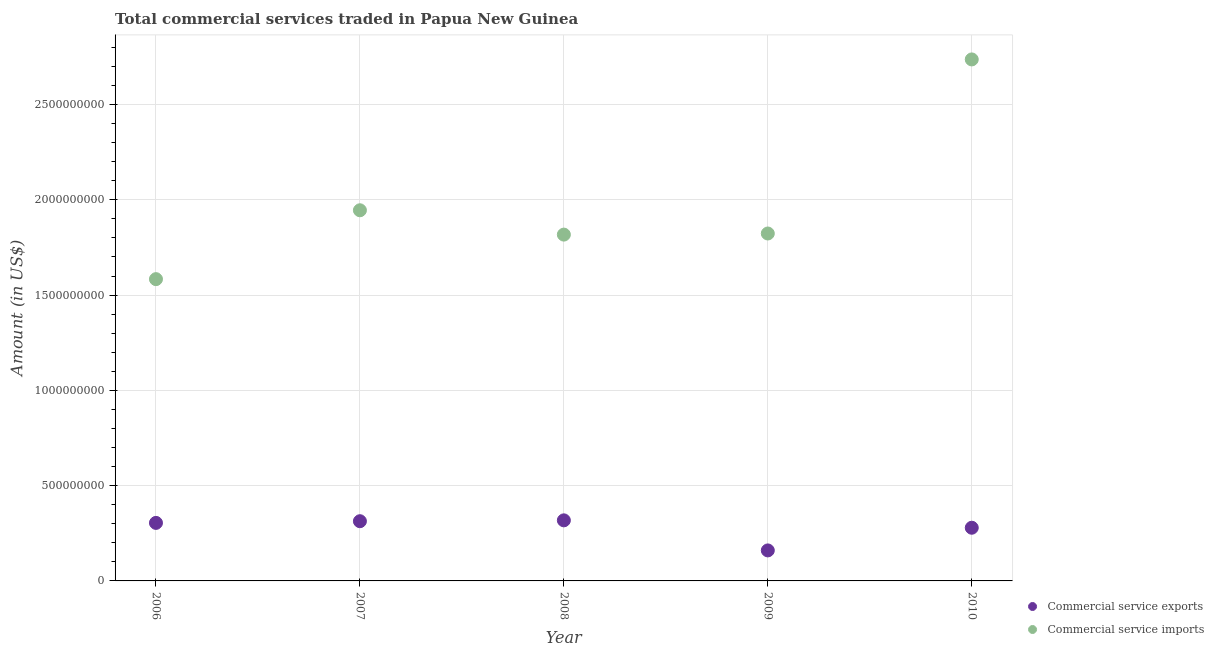How many different coloured dotlines are there?
Your response must be concise. 2. What is the amount of commercial service exports in 2009?
Offer a terse response. 1.60e+08. Across all years, what is the maximum amount of commercial service imports?
Provide a short and direct response. 2.74e+09. Across all years, what is the minimum amount of commercial service imports?
Your answer should be compact. 1.58e+09. In which year was the amount of commercial service exports minimum?
Give a very brief answer. 2009. What is the total amount of commercial service exports in the graph?
Make the answer very short. 1.38e+09. What is the difference between the amount of commercial service imports in 2007 and that in 2009?
Provide a succinct answer. 1.22e+08. What is the difference between the amount of commercial service imports in 2010 and the amount of commercial service exports in 2006?
Keep it short and to the point. 2.43e+09. What is the average amount of commercial service exports per year?
Your answer should be compact. 2.75e+08. In the year 2010, what is the difference between the amount of commercial service imports and amount of commercial service exports?
Give a very brief answer. 2.46e+09. In how many years, is the amount of commercial service imports greater than 100000000 US$?
Your answer should be compact. 5. What is the ratio of the amount of commercial service exports in 2006 to that in 2009?
Offer a very short reply. 1.9. What is the difference between the highest and the second highest amount of commercial service exports?
Offer a terse response. 4.53e+06. What is the difference between the highest and the lowest amount of commercial service imports?
Provide a succinct answer. 1.15e+09. Is the sum of the amount of commercial service exports in 2006 and 2008 greater than the maximum amount of commercial service imports across all years?
Offer a terse response. No. Is the amount of commercial service exports strictly greater than the amount of commercial service imports over the years?
Give a very brief answer. No. Is the amount of commercial service imports strictly less than the amount of commercial service exports over the years?
Ensure brevity in your answer.  No. How many years are there in the graph?
Your answer should be compact. 5. How are the legend labels stacked?
Offer a very short reply. Vertical. What is the title of the graph?
Provide a short and direct response. Total commercial services traded in Papua New Guinea. Does "Investment" appear as one of the legend labels in the graph?
Offer a very short reply. No. What is the Amount (in US$) of Commercial service exports in 2006?
Make the answer very short. 3.05e+08. What is the Amount (in US$) of Commercial service imports in 2006?
Offer a terse response. 1.58e+09. What is the Amount (in US$) of Commercial service exports in 2007?
Offer a terse response. 3.13e+08. What is the Amount (in US$) in Commercial service imports in 2007?
Offer a terse response. 1.95e+09. What is the Amount (in US$) of Commercial service exports in 2008?
Provide a succinct answer. 3.18e+08. What is the Amount (in US$) in Commercial service imports in 2008?
Provide a succinct answer. 1.82e+09. What is the Amount (in US$) in Commercial service exports in 2009?
Provide a succinct answer. 1.60e+08. What is the Amount (in US$) of Commercial service imports in 2009?
Keep it short and to the point. 1.82e+09. What is the Amount (in US$) of Commercial service exports in 2010?
Ensure brevity in your answer.  2.79e+08. What is the Amount (in US$) in Commercial service imports in 2010?
Offer a very short reply. 2.74e+09. Across all years, what is the maximum Amount (in US$) in Commercial service exports?
Provide a succinct answer. 3.18e+08. Across all years, what is the maximum Amount (in US$) in Commercial service imports?
Keep it short and to the point. 2.74e+09. Across all years, what is the minimum Amount (in US$) in Commercial service exports?
Your response must be concise. 1.60e+08. Across all years, what is the minimum Amount (in US$) in Commercial service imports?
Provide a succinct answer. 1.58e+09. What is the total Amount (in US$) in Commercial service exports in the graph?
Keep it short and to the point. 1.38e+09. What is the total Amount (in US$) of Commercial service imports in the graph?
Make the answer very short. 9.91e+09. What is the difference between the Amount (in US$) in Commercial service exports in 2006 and that in 2007?
Offer a terse response. -8.85e+06. What is the difference between the Amount (in US$) in Commercial service imports in 2006 and that in 2007?
Make the answer very short. -3.61e+08. What is the difference between the Amount (in US$) of Commercial service exports in 2006 and that in 2008?
Offer a very short reply. -1.34e+07. What is the difference between the Amount (in US$) of Commercial service imports in 2006 and that in 2008?
Ensure brevity in your answer.  -2.34e+08. What is the difference between the Amount (in US$) of Commercial service exports in 2006 and that in 2009?
Make the answer very short. 1.44e+08. What is the difference between the Amount (in US$) in Commercial service imports in 2006 and that in 2009?
Offer a terse response. -2.40e+08. What is the difference between the Amount (in US$) in Commercial service exports in 2006 and that in 2010?
Your answer should be compact. 2.54e+07. What is the difference between the Amount (in US$) of Commercial service imports in 2006 and that in 2010?
Make the answer very short. -1.15e+09. What is the difference between the Amount (in US$) of Commercial service exports in 2007 and that in 2008?
Offer a very short reply. -4.53e+06. What is the difference between the Amount (in US$) in Commercial service imports in 2007 and that in 2008?
Your answer should be compact. 1.28e+08. What is the difference between the Amount (in US$) in Commercial service exports in 2007 and that in 2009?
Offer a very short reply. 1.53e+08. What is the difference between the Amount (in US$) of Commercial service imports in 2007 and that in 2009?
Ensure brevity in your answer.  1.22e+08. What is the difference between the Amount (in US$) in Commercial service exports in 2007 and that in 2010?
Offer a very short reply. 3.43e+07. What is the difference between the Amount (in US$) of Commercial service imports in 2007 and that in 2010?
Make the answer very short. -7.92e+08. What is the difference between the Amount (in US$) in Commercial service exports in 2008 and that in 2009?
Keep it short and to the point. 1.58e+08. What is the difference between the Amount (in US$) of Commercial service imports in 2008 and that in 2009?
Provide a succinct answer. -5.82e+06. What is the difference between the Amount (in US$) in Commercial service exports in 2008 and that in 2010?
Give a very brief answer. 3.88e+07. What is the difference between the Amount (in US$) of Commercial service imports in 2008 and that in 2010?
Give a very brief answer. -9.19e+08. What is the difference between the Amount (in US$) of Commercial service exports in 2009 and that in 2010?
Provide a short and direct response. -1.19e+08. What is the difference between the Amount (in US$) in Commercial service imports in 2009 and that in 2010?
Give a very brief answer. -9.14e+08. What is the difference between the Amount (in US$) in Commercial service exports in 2006 and the Amount (in US$) in Commercial service imports in 2007?
Make the answer very short. -1.64e+09. What is the difference between the Amount (in US$) in Commercial service exports in 2006 and the Amount (in US$) in Commercial service imports in 2008?
Offer a terse response. -1.51e+09. What is the difference between the Amount (in US$) in Commercial service exports in 2006 and the Amount (in US$) in Commercial service imports in 2009?
Offer a terse response. -1.52e+09. What is the difference between the Amount (in US$) in Commercial service exports in 2006 and the Amount (in US$) in Commercial service imports in 2010?
Provide a succinct answer. -2.43e+09. What is the difference between the Amount (in US$) of Commercial service exports in 2007 and the Amount (in US$) of Commercial service imports in 2008?
Offer a terse response. -1.50e+09. What is the difference between the Amount (in US$) in Commercial service exports in 2007 and the Amount (in US$) in Commercial service imports in 2009?
Your response must be concise. -1.51e+09. What is the difference between the Amount (in US$) in Commercial service exports in 2007 and the Amount (in US$) in Commercial service imports in 2010?
Offer a very short reply. -2.42e+09. What is the difference between the Amount (in US$) of Commercial service exports in 2008 and the Amount (in US$) of Commercial service imports in 2009?
Your answer should be compact. -1.51e+09. What is the difference between the Amount (in US$) of Commercial service exports in 2008 and the Amount (in US$) of Commercial service imports in 2010?
Ensure brevity in your answer.  -2.42e+09. What is the difference between the Amount (in US$) of Commercial service exports in 2009 and the Amount (in US$) of Commercial service imports in 2010?
Your response must be concise. -2.58e+09. What is the average Amount (in US$) of Commercial service exports per year?
Your answer should be compact. 2.75e+08. What is the average Amount (in US$) of Commercial service imports per year?
Provide a succinct answer. 1.98e+09. In the year 2006, what is the difference between the Amount (in US$) in Commercial service exports and Amount (in US$) in Commercial service imports?
Your response must be concise. -1.28e+09. In the year 2007, what is the difference between the Amount (in US$) in Commercial service exports and Amount (in US$) in Commercial service imports?
Your answer should be very brief. -1.63e+09. In the year 2008, what is the difference between the Amount (in US$) of Commercial service exports and Amount (in US$) of Commercial service imports?
Keep it short and to the point. -1.50e+09. In the year 2009, what is the difference between the Amount (in US$) in Commercial service exports and Amount (in US$) in Commercial service imports?
Keep it short and to the point. -1.66e+09. In the year 2010, what is the difference between the Amount (in US$) of Commercial service exports and Amount (in US$) of Commercial service imports?
Give a very brief answer. -2.46e+09. What is the ratio of the Amount (in US$) in Commercial service exports in 2006 to that in 2007?
Your answer should be compact. 0.97. What is the ratio of the Amount (in US$) of Commercial service imports in 2006 to that in 2007?
Your answer should be very brief. 0.81. What is the ratio of the Amount (in US$) in Commercial service exports in 2006 to that in 2008?
Ensure brevity in your answer.  0.96. What is the ratio of the Amount (in US$) of Commercial service imports in 2006 to that in 2008?
Make the answer very short. 0.87. What is the ratio of the Amount (in US$) in Commercial service exports in 2006 to that in 2009?
Your answer should be very brief. 1.9. What is the ratio of the Amount (in US$) of Commercial service imports in 2006 to that in 2009?
Offer a very short reply. 0.87. What is the ratio of the Amount (in US$) of Commercial service exports in 2006 to that in 2010?
Keep it short and to the point. 1.09. What is the ratio of the Amount (in US$) in Commercial service imports in 2006 to that in 2010?
Ensure brevity in your answer.  0.58. What is the ratio of the Amount (in US$) in Commercial service exports in 2007 to that in 2008?
Offer a terse response. 0.99. What is the ratio of the Amount (in US$) in Commercial service imports in 2007 to that in 2008?
Your answer should be compact. 1.07. What is the ratio of the Amount (in US$) in Commercial service exports in 2007 to that in 2009?
Make the answer very short. 1.96. What is the ratio of the Amount (in US$) of Commercial service imports in 2007 to that in 2009?
Your answer should be compact. 1.07. What is the ratio of the Amount (in US$) of Commercial service exports in 2007 to that in 2010?
Provide a short and direct response. 1.12. What is the ratio of the Amount (in US$) of Commercial service imports in 2007 to that in 2010?
Give a very brief answer. 0.71. What is the ratio of the Amount (in US$) in Commercial service exports in 2008 to that in 2009?
Your answer should be very brief. 1.99. What is the ratio of the Amount (in US$) of Commercial service exports in 2008 to that in 2010?
Your answer should be very brief. 1.14. What is the ratio of the Amount (in US$) in Commercial service imports in 2008 to that in 2010?
Provide a succinct answer. 0.66. What is the ratio of the Amount (in US$) of Commercial service exports in 2009 to that in 2010?
Ensure brevity in your answer.  0.57. What is the ratio of the Amount (in US$) of Commercial service imports in 2009 to that in 2010?
Your answer should be compact. 0.67. What is the difference between the highest and the second highest Amount (in US$) in Commercial service exports?
Make the answer very short. 4.53e+06. What is the difference between the highest and the second highest Amount (in US$) in Commercial service imports?
Provide a short and direct response. 7.92e+08. What is the difference between the highest and the lowest Amount (in US$) of Commercial service exports?
Provide a short and direct response. 1.58e+08. What is the difference between the highest and the lowest Amount (in US$) in Commercial service imports?
Provide a succinct answer. 1.15e+09. 